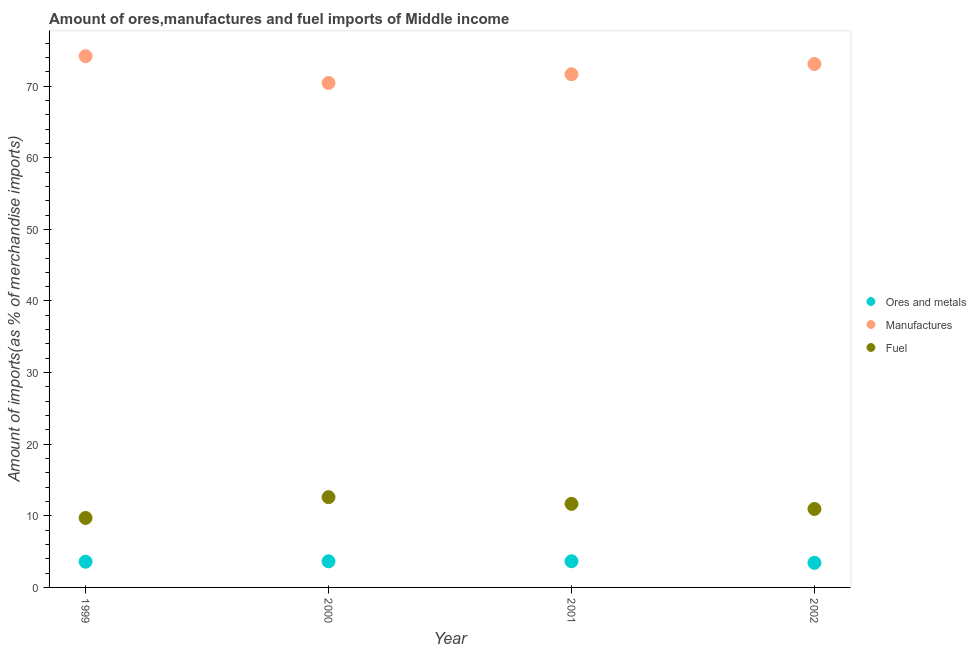What is the percentage of fuel imports in 2000?
Make the answer very short. 12.6. Across all years, what is the maximum percentage of fuel imports?
Your answer should be compact. 12.6. Across all years, what is the minimum percentage of ores and metals imports?
Provide a succinct answer. 3.43. What is the total percentage of ores and metals imports in the graph?
Your answer should be very brief. 14.33. What is the difference between the percentage of ores and metals imports in 2000 and that in 2002?
Make the answer very short. 0.21. What is the difference between the percentage of manufactures imports in 1999 and the percentage of ores and metals imports in 2000?
Make the answer very short. 70.54. What is the average percentage of ores and metals imports per year?
Your response must be concise. 3.58. In the year 2001, what is the difference between the percentage of manufactures imports and percentage of fuel imports?
Provide a short and direct response. 60. In how many years, is the percentage of fuel imports greater than 64 %?
Make the answer very short. 0. What is the ratio of the percentage of fuel imports in 2000 to that in 2001?
Your response must be concise. 1.08. What is the difference between the highest and the second highest percentage of fuel imports?
Keep it short and to the point. 0.94. What is the difference between the highest and the lowest percentage of fuel imports?
Provide a succinct answer. 2.9. In how many years, is the percentage of ores and metals imports greater than the average percentage of ores and metals imports taken over all years?
Provide a short and direct response. 3. Is it the case that in every year, the sum of the percentage of ores and metals imports and percentage of manufactures imports is greater than the percentage of fuel imports?
Give a very brief answer. Yes. Does the percentage of fuel imports monotonically increase over the years?
Offer a terse response. No. Is the percentage of fuel imports strictly greater than the percentage of ores and metals imports over the years?
Provide a short and direct response. Yes. Where does the legend appear in the graph?
Provide a succinct answer. Center right. What is the title of the graph?
Offer a terse response. Amount of ores,manufactures and fuel imports of Middle income. Does "Neonatal" appear as one of the legend labels in the graph?
Your answer should be very brief. No. What is the label or title of the Y-axis?
Ensure brevity in your answer.  Amount of imports(as % of merchandise imports). What is the Amount of imports(as % of merchandise imports) in Ores and metals in 1999?
Your response must be concise. 3.59. What is the Amount of imports(as % of merchandise imports) of Manufactures in 1999?
Provide a succinct answer. 74.19. What is the Amount of imports(as % of merchandise imports) in Fuel in 1999?
Ensure brevity in your answer.  9.7. What is the Amount of imports(as % of merchandise imports) in Ores and metals in 2000?
Keep it short and to the point. 3.65. What is the Amount of imports(as % of merchandise imports) in Manufactures in 2000?
Keep it short and to the point. 70.44. What is the Amount of imports(as % of merchandise imports) of Fuel in 2000?
Provide a succinct answer. 12.6. What is the Amount of imports(as % of merchandise imports) in Ores and metals in 2001?
Provide a short and direct response. 3.66. What is the Amount of imports(as % of merchandise imports) of Manufactures in 2001?
Make the answer very short. 71.66. What is the Amount of imports(as % of merchandise imports) in Fuel in 2001?
Offer a terse response. 11.67. What is the Amount of imports(as % of merchandise imports) of Ores and metals in 2002?
Your answer should be very brief. 3.43. What is the Amount of imports(as % of merchandise imports) of Manufactures in 2002?
Your answer should be compact. 73.09. What is the Amount of imports(as % of merchandise imports) of Fuel in 2002?
Provide a succinct answer. 10.96. Across all years, what is the maximum Amount of imports(as % of merchandise imports) in Ores and metals?
Provide a short and direct response. 3.66. Across all years, what is the maximum Amount of imports(as % of merchandise imports) of Manufactures?
Keep it short and to the point. 74.19. Across all years, what is the maximum Amount of imports(as % of merchandise imports) of Fuel?
Offer a terse response. 12.6. Across all years, what is the minimum Amount of imports(as % of merchandise imports) in Ores and metals?
Your response must be concise. 3.43. Across all years, what is the minimum Amount of imports(as % of merchandise imports) in Manufactures?
Your response must be concise. 70.44. Across all years, what is the minimum Amount of imports(as % of merchandise imports) of Fuel?
Your response must be concise. 9.7. What is the total Amount of imports(as % of merchandise imports) of Ores and metals in the graph?
Offer a terse response. 14.33. What is the total Amount of imports(as % of merchandise imports) in Manufactures in the graph?
Your answer should be compact. 289.39. What is the total Amount of imports(as % of merchandise imports) of Fuel in the graph?
Give a very brief answer. 44.93. What is the difference between the Amount of imports(as % of merchandise imports) in Ores and metals in 1999 and that in 2000?
Offer a very short reply. -0.06. What is the difference between the Amount of imports(as % of merchandise imports) in Manufactures in 1999 and that in 2000?
Make the answer very short. 3.74. What is the difference between the Amount of imports(as % of merchandise imports) in Fuel in 1999 and that in 2000?
Your answer should be compact. -2.9. What is the difference between the Amount of imports(as % of merchandise imports) in Ores and metals in 1999 and that in 2001?
Your answer should be very brief. -0.07. What is the difference between the Amount of imports(as % of merchandise imports) of Manufactures in 1999 and that in 2001?
Ensure brevity in your answer.  2.52. What is the difference between the Amount of imports(as % of merchandise imports) in Fuel in 1999 and that in 2001?
Offer a very short reply. -1.96. What is the difference between the Amount of imports(as % of merchandise imports) in Ores and metals in 1999 and that in 2002?
Keep it short and to the point. 0.16. What is the difference between the Amount of imports(as % of merchandise imports) in Manufactures in 1999 and that in 2002?
Your response must be concise. 1.09. What is the difference between the Amount of imports(as % of merchandise imports) of Fuel in 1999 and that in 2002?
Your response must be concise. -1.26. What is the difference between the Amount of imports(as % of merchandise imports) of Ores and metals in 2000 and that in 2001?
Provide a succinct answer. -0.01. What is the difference between the Amount of imports(as % of merchandise imports) of Manufactures in 2000 and that in 2001?
Give a very brief answer. -1.22. What is the difference between the Amount of imports(as % of merchandise imports) of Fuel in 2000 and that in 2001?
Ensure brevity in your answer.  0.94. What is the difference between the Amount of imports(as % of merchandise imports) of Ores and metals in 2000 and that in 2002?
Your answer should be very brief. 0.21. What is the difference between the Amount of imports(as % of merchandise imports) of Manufactures in 2000 and that in 2002?
Your answer should be compact. -2.65. What is the difference between the Amount of imports(as % of merchandise imports) of Fuel in 2000 and that in 2002?
Ensure brevity in your answer.  1.65. What is the difference between the Amount of imports(as % of merchandise imports) in Ores and metals in 2001 and that in 2002?
Your response must be concise. 0.22. What is the difference between the Amount of imports(as % of merchandise imports) in Manufactures in 2001 and that in 2002?
Make the answer very short. -1.43. What is the difference between the Amount of imports(as % of merchandise imports) in Fuel in 2001 and that in 2002?
Your answer should be compact. 0.71. What is the difference between the Amount of imports(as % of merchandise imports) in Ores and metals in 1999 and the Amount of imports(as % of merchandise imports) in Manufactures in 2000?
Provide a short and direct response. -66.85. What is the difference between the Amount of imports(as % of merchandise imports) in Ores and metals in 1999 and the Amount of imports(as % of merchandise imports) in Fuel in 2000?
Make the answer very short. -9.01. What is the difference between the Amount of imports(as % of merchandise imports) in Manufactures in 1999 and the Amount of imports(as % of merchandise imports) in Fuel in 2000?
Keep it short and to the point. 61.58. What is the difference between the Amount of imports(as % of merchandise imports) in Ores and metals in 1999 and the Amount of imports(as % of merchandise imports) in Manufactures in 2001?
Provide a short and direct response. -68.07. What is the difference between the Amount of imports(as % of merchandise imports) in Ores and metals in 1999 and the Amount of imports(as % of merchandise imports) in Fuel in 2001?
Offer a very short reply. -8.08. What is the difference between the Amount of imports(as % of merchandise imports) of Manufactures in 1999 and the Amount of imports(as % of merchandise imports) of Fuel in 2001?
Your response must be concise. 62.52. What is the difference between the Amount of imports(as % of merchandise imports) of Ores and metals in 1999 and the Amount of imports(as % of merchandise imports) of Manufactures in 2002?
Ensure brevity in your answer.  -69.5. What is the difference between the Amount of imports(as % of merchandise imports) of Ores and metals in 1999 and the Amount of imports(as % of merchandise imports) of Fuel in 2002?
Provide a short and direct response. -7.37. What is the difference between the Amount of imports(as % of merchandise imports) of Manufactures in 1999 and the Amount of imports(as % of merchandise imports) of Fuel in 2002?
Your answer should be very brief. 63.23. What is the difference between the Amount of imports(as % of merchandise imports) in Ores and metals in 2000 and the Amount of imports(as % of merchandise imports) in Manufactures in 2001?
Your answer should be compact. -68.02. What is the difference between the Amount of imports(as % of merchandise imports) of Ores and metals in 2000 and the Amount of imports(as % of merchandise imports) of Fuel in 2001?
Provide a succinct answer. -8.02. What is the difference between the Amount of imports(as % of merchandise imports) in Manufactures in 2000 and the Amount of imports(as % of merchandise imports) in Fuel in 2001?
Your answer should be compact. 58.78. What is the difference between the Amount of imports(as % of merchandise imports) in Ores and metals in 2000 and the Amount of imports(as % of merchandise imports) in Manufactures in 2002?
Keep it short and to the point. -69.44. What is the difference between the Amount of imports(as % of merchandise imports) of Ores and metals in 2000 and the Amount of imports(as % of merchandise imports) of Fuel in 2002?
Provide a short and direct response. -7.31. What is the difference between the Amount of imports(as % of merchandise imports) of Manufactures in 2000 and the Amount of imports(as % of merchandise imports) of Fuel in 2002?
Your response must be concise. 59.48. What is the difference between the Amount of imports(as % of merchandise imports) of Ores and metals in 2001 and the Amount of imports(as % of merchandise imports) of Manufactures in 2002?
Offer a terse response. -69.44. What is the difference between the Amount of imports(as % of merchandise imports) of Ores and metals in 2001 and the Amount of imports(as % of merchandise imports) of Fuel in 2002?
Keep it short and to the point. -7.3. What is the difference between the Amount of imports(as % of merchandise imports) in Manufactures in 2001 and the Amount of imports(as % of merchandise imports) in Fuel in 2002?
Keep it short and to the point. 60.71. What is the average Amount of imports(as % of merchandise imports) of Ores and metals per year?
Provide a short and direct response. 3.58. What is the average Amount of imports(as % of merchandise imports) of Manufactures per year?
Your answer should be compact. 72.35. What is the average Amount of imports(as % of merchandise imports) of Fuel per year?
Offer a terse response. 11.23. In the year 1999, what is the difference between the Amount of imports(as % of merchandise imports) of Ores and metals and Amount of imports(as % of merchandise imports) of Manufactures?
Provide a short and direct response. -70.6. In the year 1999, what is the difference between the Amount of imports(as % of merchandise imports) in Ores and metals and Amount of imports(as % of merchandise imports) in Fuel?
Provide a succinct answer. -6.11. In the year 1999, what is the difference between the Amount of imports(as % of merchandise imports) of Manufactures and Amount of imports(as % of merchandise imports) of Fuel?
Your answer should be very brief. 64.48. In the year 2000, what is the difference between the Amount of imports(as % of merchandise imports) in Ores and metals and Amount of imports(as % of merchandise imports) in Manufactures?
Your response must be concise. -66.79. In the year 2000, what is the difference between the Amount of imports(as % of merchandise imports) of Ores and metals and Amount of imports(as % of merchandise imports) of Fuel?
Your response must be concise. -8.95. In the year 2000, what is the difference between the Amount of imports(as % of merchandise imports) in Manufactures and Amount of imports(as % of merchandise imports) in Fuel?
Keep it short and to the point. 57.84. In the year 2001, what is the difference between the Amount of imports(as % of merchandise imports) of Ores and metals and Amount of imports(as % of merchandise imports) of Manufactures?
Offer a very short reply. -68.01. In the year 2001, what is the difference between the Amount of imports(as % of merchandise imports) of Ores and metals and Amount of imports(as % of merchandise imports) of Fuel?
Provide a short and direct response. -8.01. In the year 2001, what is the difference between the Amount of imports(as % of merchandise imports) in Manufactures and Amount of imports(as % of merchandise imports) in Fuel?
Provide a succinct answer. 60. In the year 2002, what is the difference between the Amount of imports(as % of merchandise imports) in Ores and metals and Amount of imports(as % of merchandise imports) in Manufactures?
Offer a terse response. -69.66. In the year 2002, what is the difference between the Amount of imports(as % of merchandise imports) in Ores and metals and Amount of imports(as % of merchandise imports) in Fuel?
Your answer should be compact. -7.52. In the year 2002, what is the difference between the Amount of imports(as % of merchandise imports) in Manufactures and Amount of imports(as % of merchandise imports) in Fuel?
Keep it short and to the point. 62.13. What is the ratio of the Amount of imports(as % of merchandise imports) in Ores and metals in 1999 to that in 2000?
Ensure brevity in your answer.  0.98. What is the ratio of the Amount of imports(as % of merchandise imports) in Manufactures in 1999 to that in 2000?
Ensure brevity in your answer.  1.05. What is the ratio of the Amount of imports(as % of merchandise imports) in Fuel in 1999 to that in 2000?
Keep it short and to the point. 0.77. What is the ratio of the Amount of imports(as % of merchandise imports) of Ores and metals in 1999 to that in 2001?
Ensure brevity in your answer.  0.98. What is the ratio of the Amount of imports(as % of merchandise imports) in Manufactures in 1999 to that in 2001?
Keep it short and to the point. 1.04. What is the ratio of the Amount of imports(as % of merchandise imports) of Fuel in 1999 to that in 2001?
Offer a very short reply. 0.83. What is the ratio of the Amount of imports(as % of merchandise imports) of Ores and metals in 1999 to that in 2002?
Provide a short and direct response. 1.05. What is the ratio of the Amount of imports(as % of merchandise imports) of Fuel in 1999 to that in 2002?
Provide a short and direct response. 0.89. What is the ratio of the Amount of imports(as % of merchandise imports) in Ores and metals in 2000 to that in 2001?
Your response must be concise. 1. What is the ratio of the Amount of imports(as % of merchandise imports) in Manufactures in 2000 to that in 2001?
Offer a terse response. 0.98. What is the ratio of the Amount of imports(as % of merchandise imports) of Fuel in 2000 to that in 2001?
Your answer should be very brief. 1.08. What is the ratio of the Amount of imports(as % of merchandise imports) of Ores and metals in 2000 to that in 2002?
Provide a succinct answer. 1.06. What is the ratio of the Amount of imports(as % of merchandise imports) of Manufactures in 2000 to that in 2002?
Provide a succinct answer. 0.96. What is the ratio of the Amount of imports(as % of merchandise imports) in Fuel in 2000 to that in 2002?
Provide a short and direct response. 1.15. What is the ratio of the Amount of imports(as % of merchandise imports) in Ores and metals in 2001 to that in 2002?
Provide a short and direct response. 1.06. What is the ratio of the Amount of imports(as % of merchandise imports) in Manufactures in 2001 to that in 2002?
Offer a terse response. 0.98. What is the ratio of the Amount of imports(as % of merchandise imports) in Fuel in 2001 to that in 2002?
Make the answer very short. 1.06. What is the difference between the highest and the second highest Amount of imports(as % of merchandise imports) of Ores and metals?
Keep it short and to the point. 0.01. What is the difference between the highest and the second highest Amount of imports(as % of merchandise imports) of Manufactures?
Ensure brevity in your answer.  1.09. What is the difference between the highest and the second highest Amount of imports(as % of merchandise imports) in Fuel?
Offer a terse response. 0.94. What is the difference between the highest and the lowest Amount of imports(as % of merchandise imports) of Ores and metals?
Make the answer very short. 0.22. What is the difference between the highest and the lowest Amount of imports(as % of merchandise imports) of Manufactures?
Ensure brevity in your answer.  3.74. What is the difference between the highest and the lowest Amount of imports(as % of merchandise imports) of Fuel?
Ensure brevity in your answer.  2.9. 